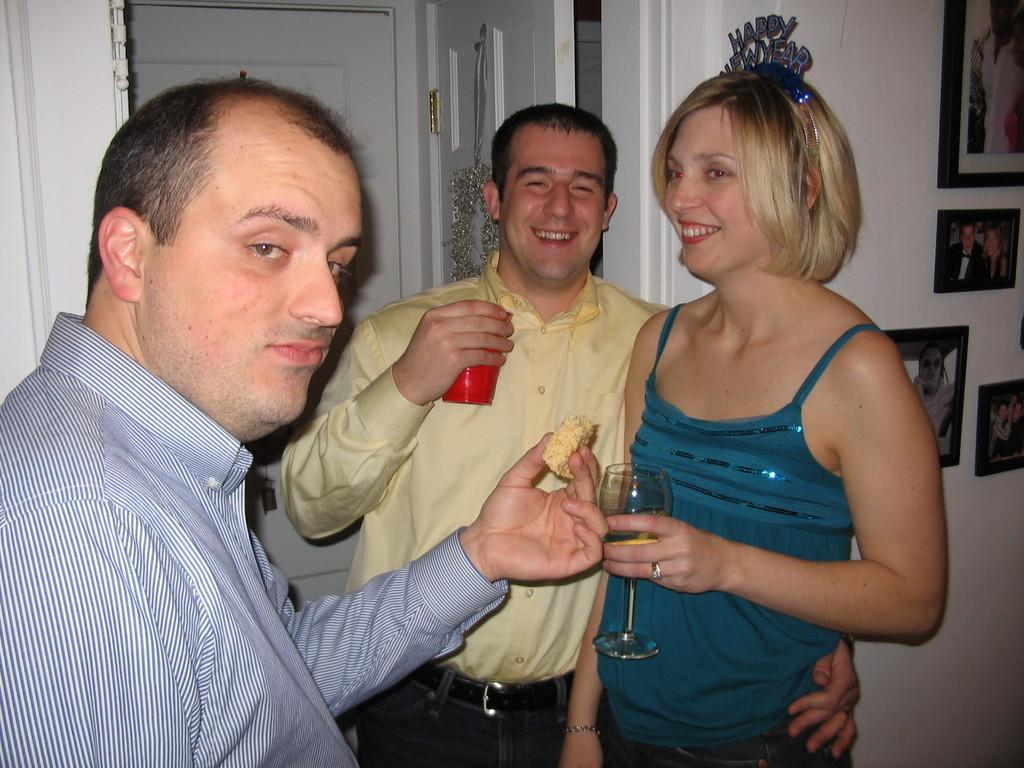How many people are in the image? There are three people in the image. What are two of the people doing with their hands? Two of the people are holding glasses. What is the facial expression of the two people holding glasses? The two people holding glasses are smiling. What is the third person holding in the image? One person is holding food. What can be seen on the wall in the image? There are pictures on the wall. What type of arithmetic problem is being solved by the people in the image? There is no arithmetic problem being solved in the image; the people are holding glasses and food. Is there any fire visible in the image? No, there is no fire present in the image. 